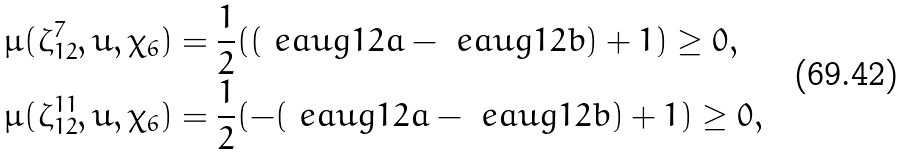<formula> <loc_0><loc_0><loc_500><loc_500>& \mu ( \zeta _ { 1 2 } ^ { 7 } , u , \chi _ { 6 } ) = \frac { 1 } { 2 } ( ( \ e a u g { 1 2 a } - \ e a u g { 1 2 b } ) + 1 ) \geq 0 , \\ & \mu ( \zeta _ { 1 2 } ^ { 1 1 } , u , \chi _ { 6 } ) = \frac { 1 } { 2 } ( - ( \ e a u g { 1 2 a } - \ e a u g { 1 2 b } ) + 1 ) \geq 0 ,</formula> 